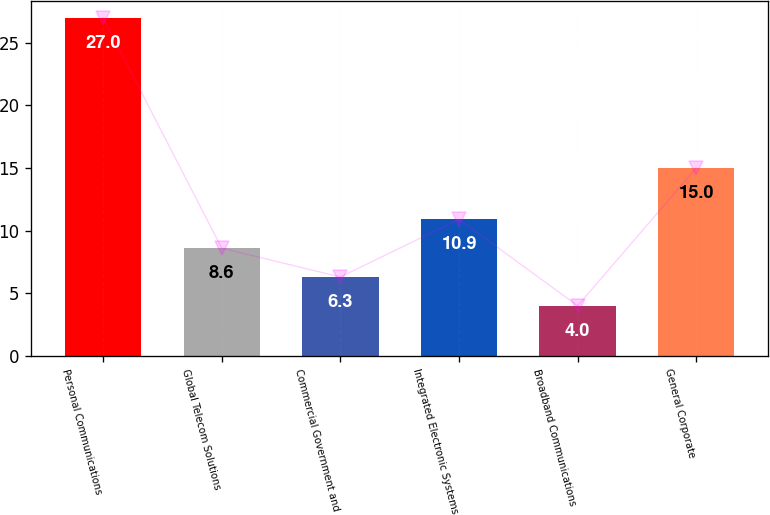Convert chart. <chart><loc_0><loc_0><loc_500><loc_500><bar_chart><fcel>Personal Communications<fcel>Global Telecom Solutions<fcel>Commercial Government and<fcel>Integrated Electronic Systems<fcel>Broadband Communications<fcel>General Corporate<nl><fcel>27<fcel>8.6<fcel>6.3<fcel>10.9<fcel>4<fcel>15<nl></chart> 